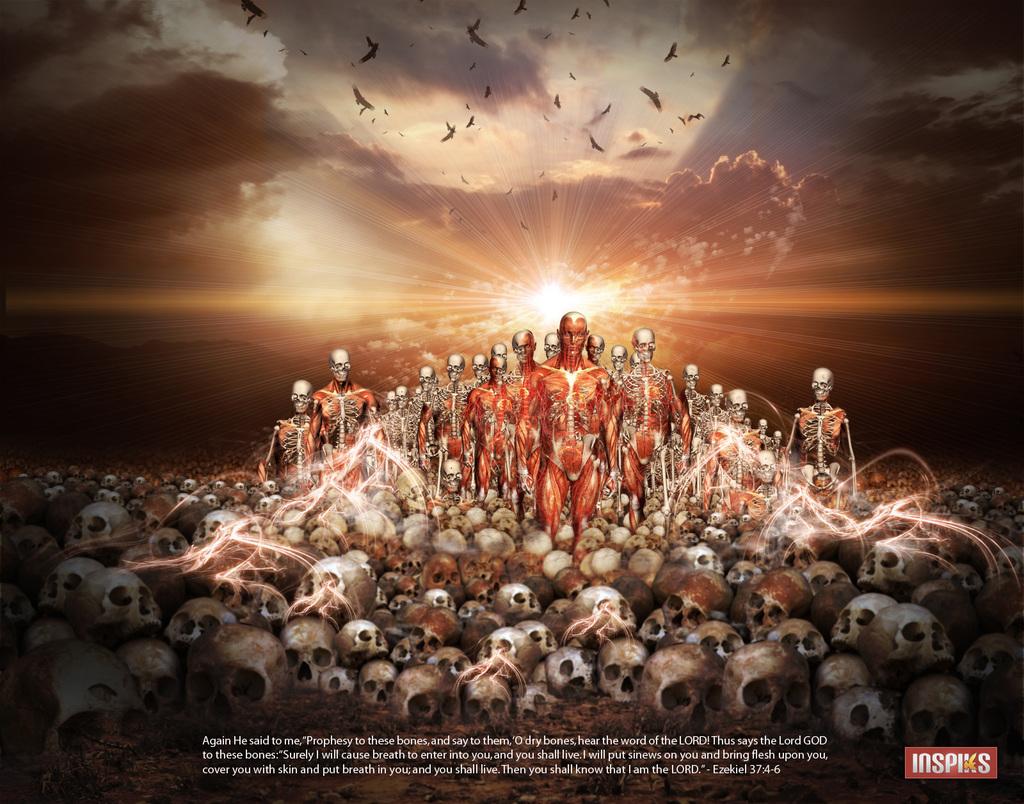What does it say in the bottom right corner?
Provide a succinct answer. Inspiks. What does the small print say?
Your answer should be very brief. Ezekiel 37:4-6. 